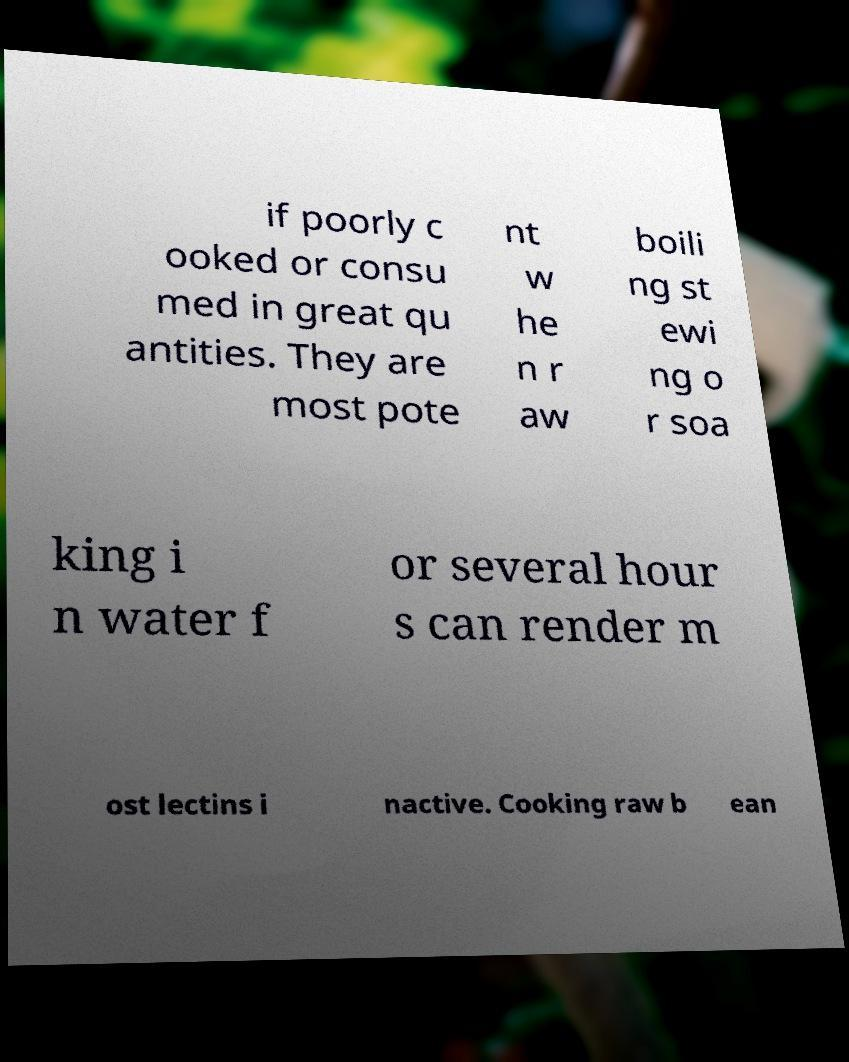Could you extract and type out the text from this image? if poorly c ooked or consu med in great qu antities. They are most pote nt w he n r aw boili ng st ewi ng o r soa king i n water f or several hour s can render m ost lectins i nactive. Cooking raw b ean 